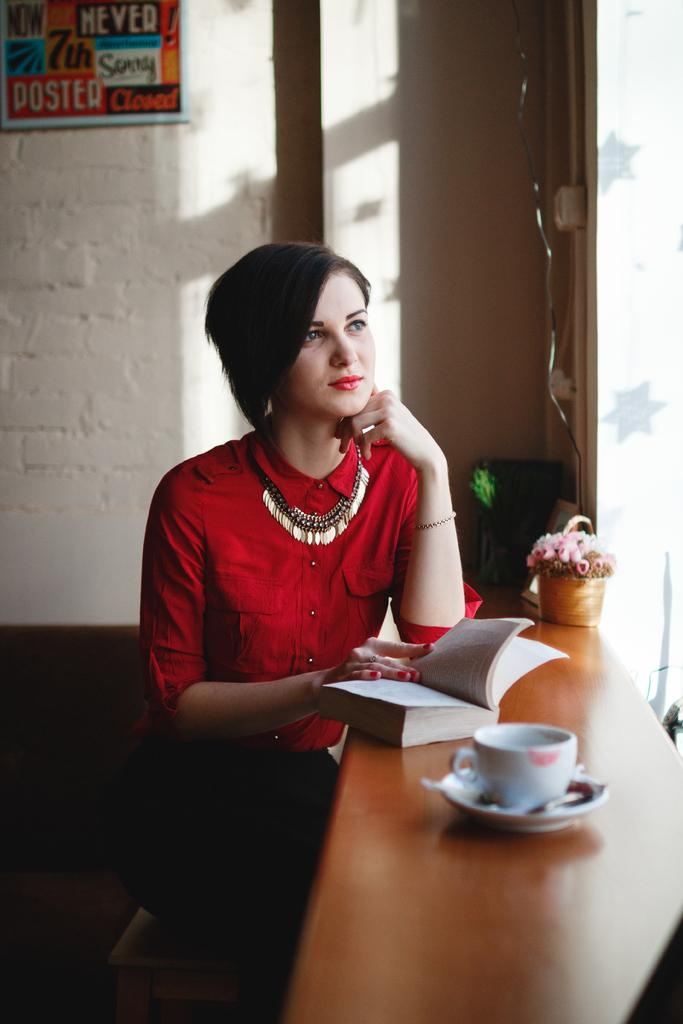What is placed over the wall in the image? There is a board over a wall in the image. What is the woman in the image doing? The woman is sitting in front of a table in the image. What is the woman holding in her hand? The woman is holding a book in her hand. What objects can be seen on the table in the image? There is a cup, a saucer, and a flower vase on the table in the image. How many girls are playing with the cat in the image? There are no girls or cats present in the image. What type of rice is being served in the image? There is no rice present in the image. 